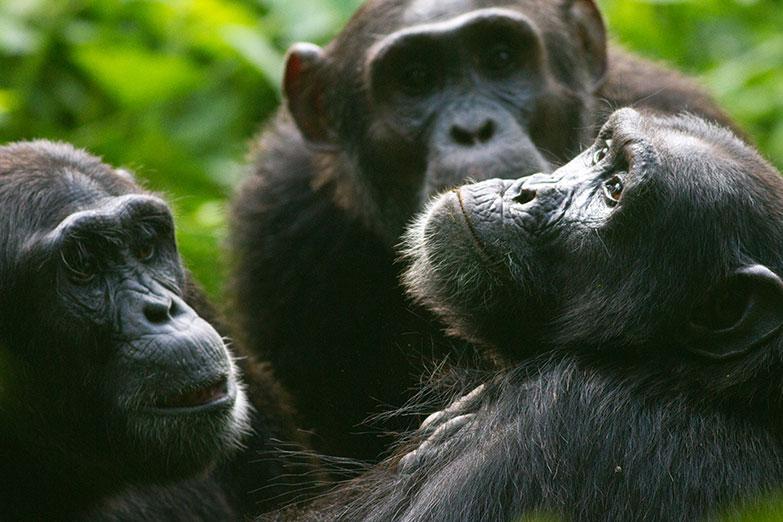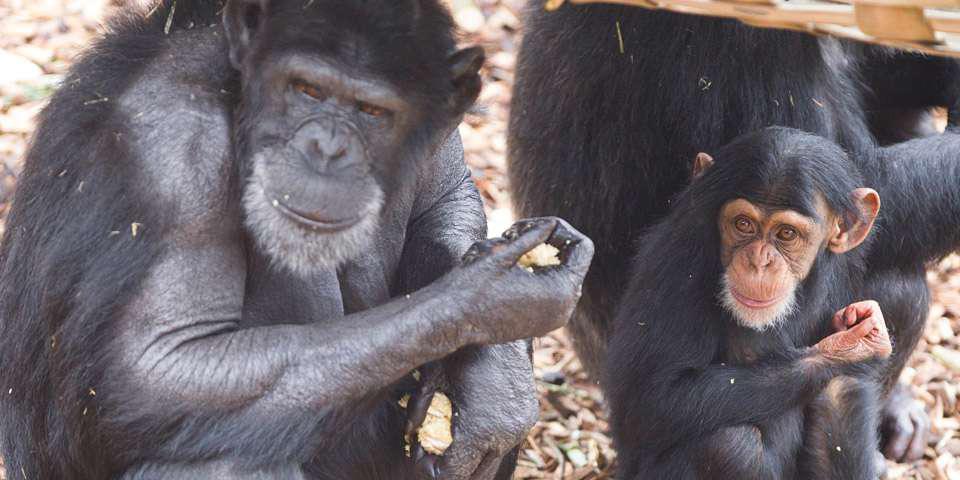The first image is the image on the left, the second image is the image on the right. For the images shown, is this caption "There are more animals in the image on the right." true? Answer yes or no. No. 